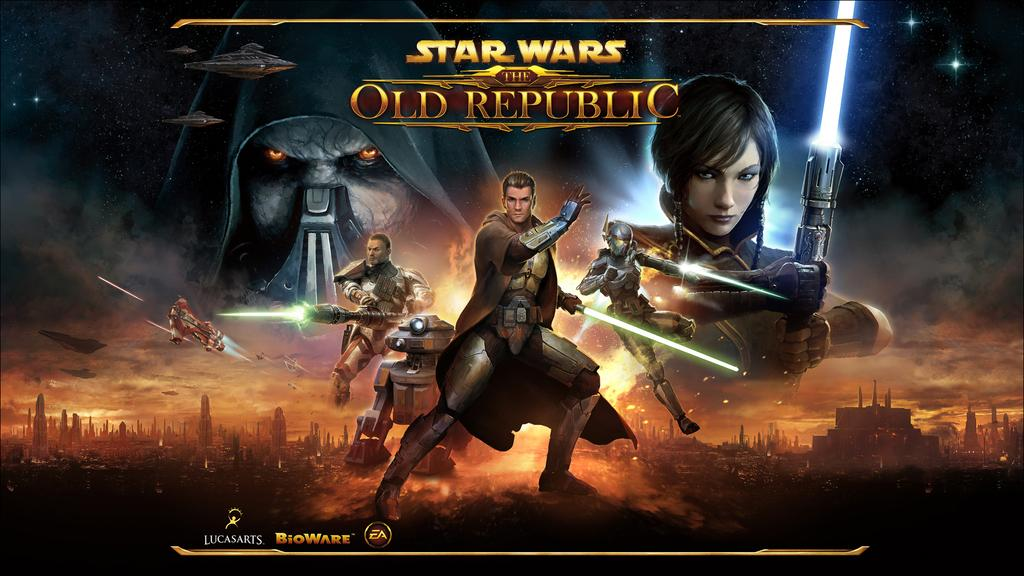<image>
Describe the image concisely. a group of cartoons from star wars the old republic 